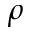Convert formula to latex. <formula><loc_0><loc_0><loc_500><loc_500>\rho</formula> 